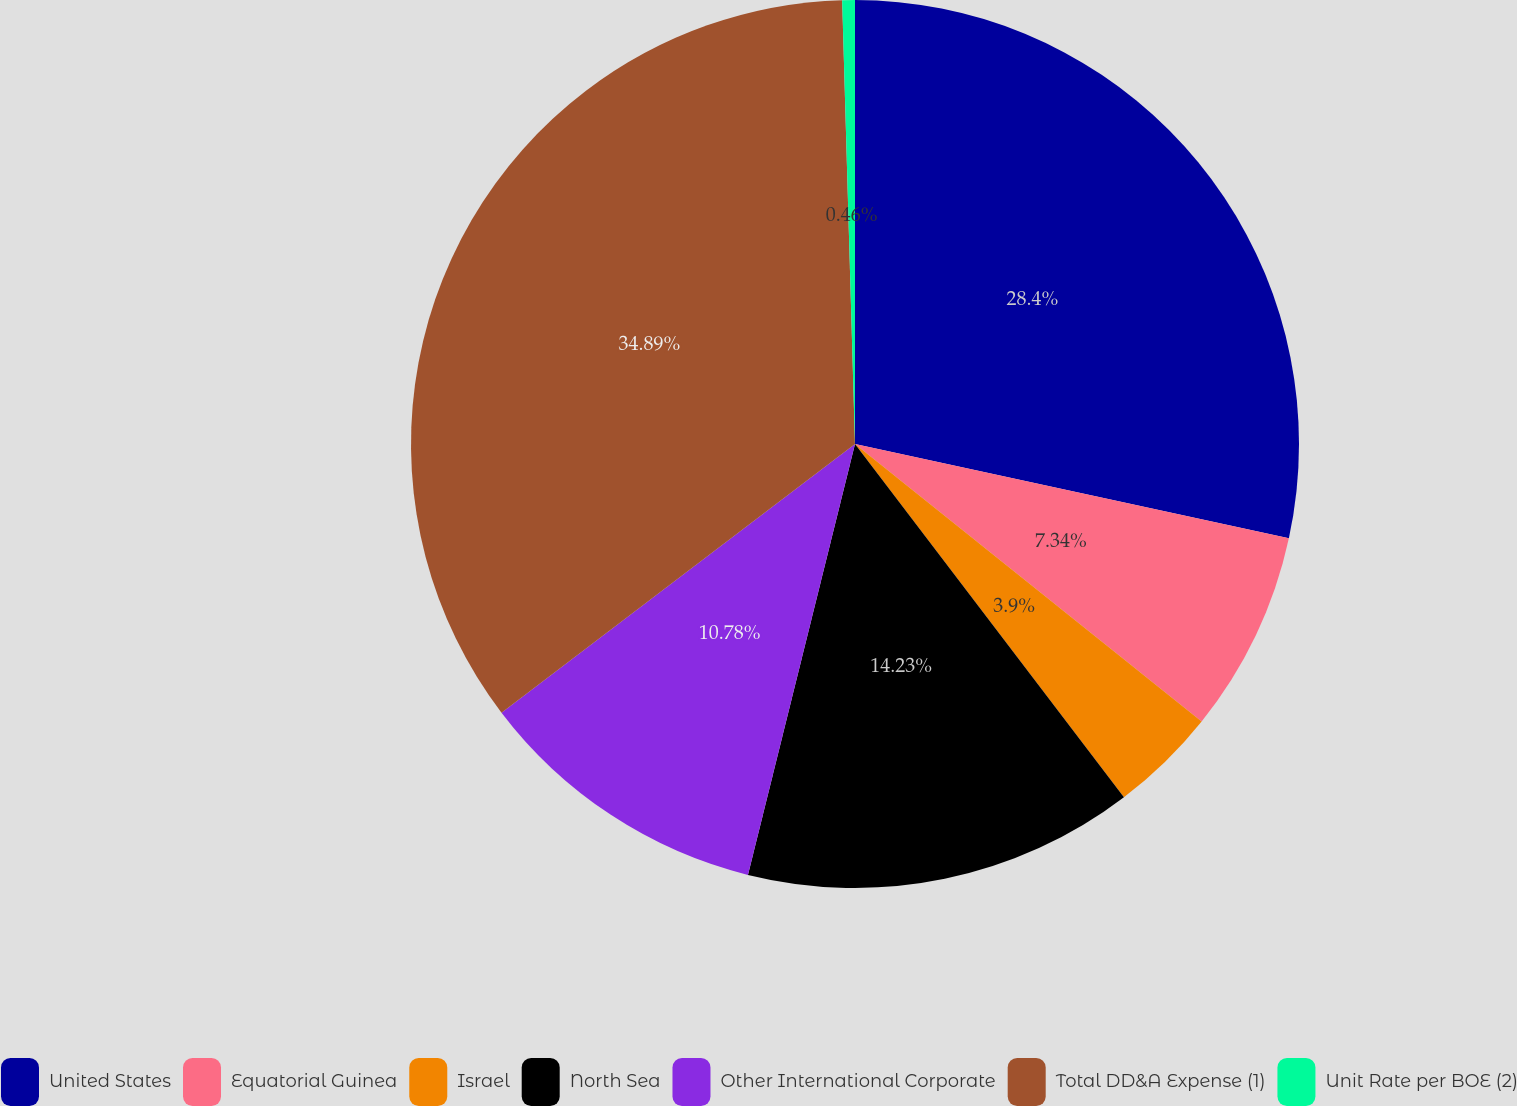<chart> <loc_0><loc_0><loc_500><loc_500><pie_chart><fcel>United States<fcel>Equatorial Guinea<fcel>Israel<fcel>North Sea<fcel>Other International Corporate<fcel>Total DD&A Expense (1)<fcel>Unit Rate per BOE (2)<nl><fcel>28.4%<fcel>7.34%<fcel>3.9%<fcel>14.23%<fcel>10.78%<fcel>34.88%<fcel>0.46%<nl></chart> 